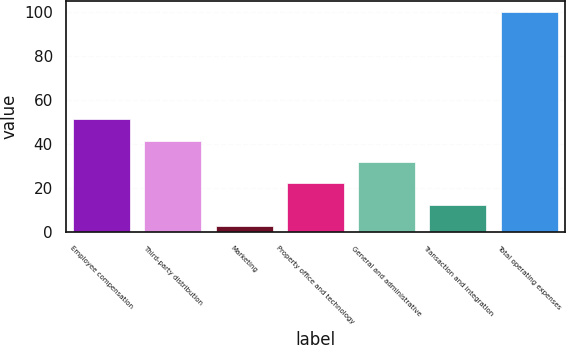<chart> <loc_0><loc_0><loc_500><loc_500><bar_chart><fcel>Employee compensation<fcel>Third-party distribution<fcel>Marketing<fcel>Property office and technology<fcel>General and administrative<fcel>Transaction and integration<fcel>Total operating expenses<nl><fcel>51.35<fcel>41.62<fcel>2.7<fcel>22.16<fcel>31.89<fcel>12.43<fcel>100<nl></chart> 